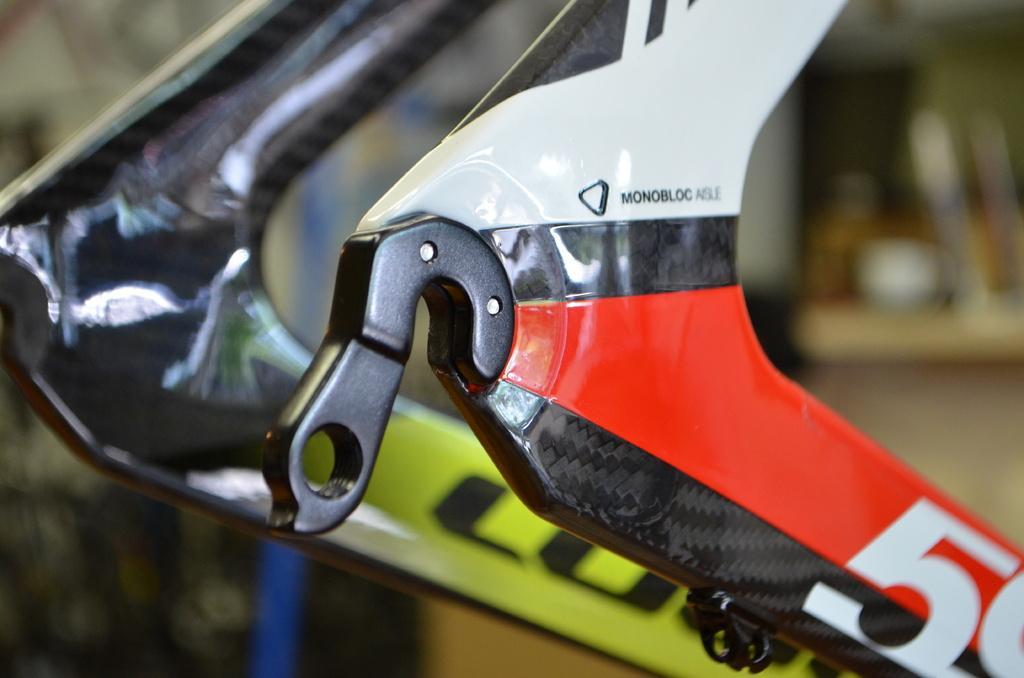Describe this image in one or two sentences. This is a zoomed in picture. In the center there is a metal object. The background of the image is very blurry. 